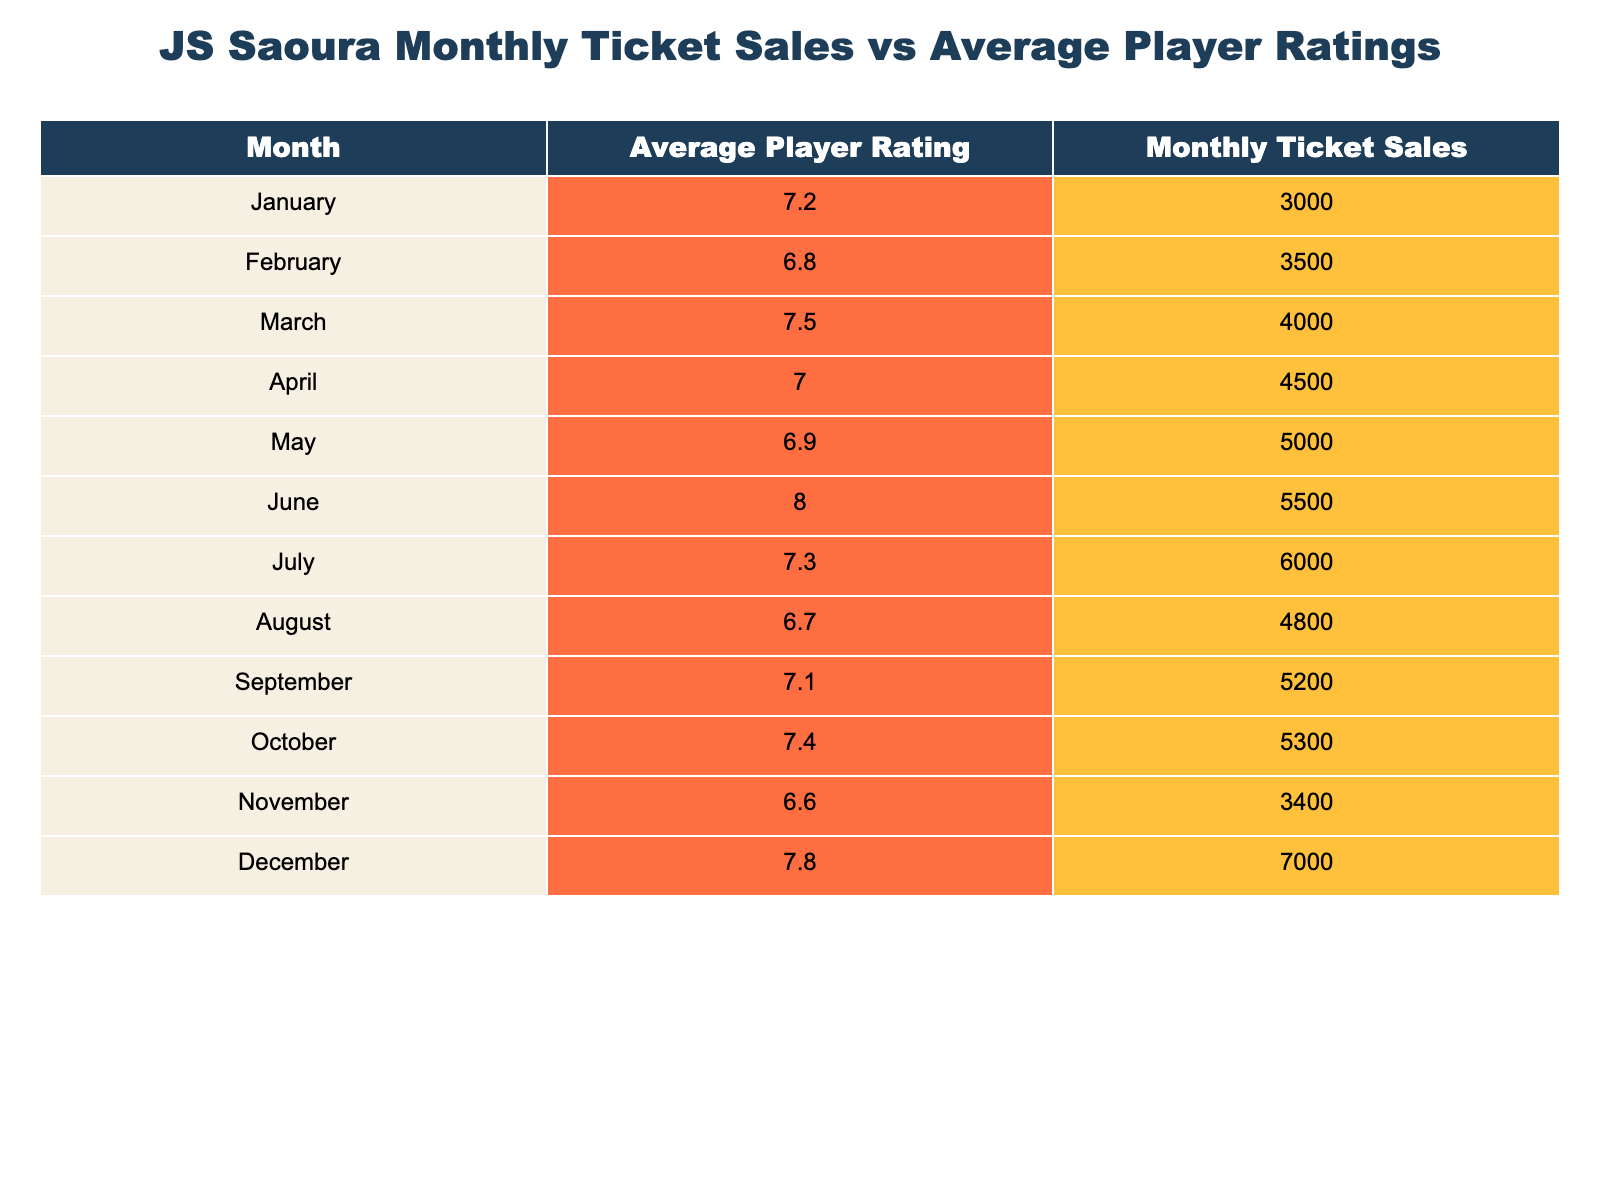What is the average player rating in June? The table shows the average player rating for June as 8.0. It can be directly retrieved from the table without any calculations.
Answer: 8.0 In which month did JS Saoura achieve the highest monthly ticket sales? The highest monthly ticket sales of 7000 were recorded in December. This is a specific value found directly in the ticket sales column.
Answer: December What is the total ticket sales for the months of January to April? To find the total ticket sales from January to April, add the monthly sales: 3000 (January) + 3500 (February) + 4000 (March) + 4500 (April) = 18000.
Answer: 18000 Is the average player rating higher in June than in May? The average player rating in June is 8.0, while in May it is 6.9. Since 8.0 is greater than 6.9, the statement is true.
Answer: Yes What was the monthly ticket sales in September compared to the average player rating that month? The monthly ticket sales in September were 5200, and the average player rating was 7.1. While these are two separate figures, the question aims to see how they relate. The sales number is significantly higher than the player rating when put in percentage considerately.
Answer: September had 5200 tickets sold with a rating of 7.1 What is the difference between the average player rating in July and the average rating in November? The average player rating in July is 7.3, and in November, it is 6.6. To find the difference, subtract the two values: 7.3 - 6.6 = 0.7.
Answer: 0.7 Which month had a player rating lower than 7 across the year? Looking at the player ratings, February (6.8), May (6.9), August (6.7), and November (6.6) had ratings below 7, indicating multiple months met this criteria. This requires scanning through the table and identifying the months accordingly.
Answer: February, May, August, November If the average rating increases by 0.5 in October, what would it be compared to September? The average rating for September is 7.1. If it increases by 0.5, then it would be 7.1 + 0.5 = 7.6. Comparatively, the actual rating in October is 7.4, thus showing a minor discrepancy when summarizing data.
Answer: 7.6 How do monthly ticket sales correlate with the average player rating based on the data provided? By analyzing the data, it seems that higher player ratings correspond with increased ticket sales. For instance, sales are highest in December (7000) with ratings higher in other months showing positive results. This indicates a potential trend that improved player performance could bolster attendance.
Answer: Higher ratings coincide with increased ticket sales 